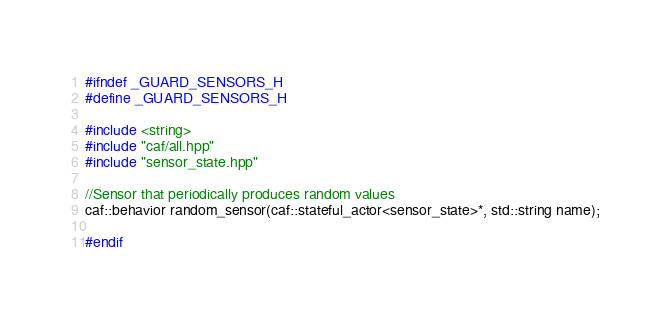Convert code to text. <code><loc_0><loc_0><loc_500><loc_500><_C++_>#ifndef _GUARD_SENSORS_H
#define _GUARD_SENSORS_H

#include <string> 
#include "caf/all.hpp"
#include "sensor_state.hpp"

//Sensor that periodically produces random values
caf::behavior random_sensor(caf::stateful_actor<sensor_state>*, std::string name);

#endif</code> 